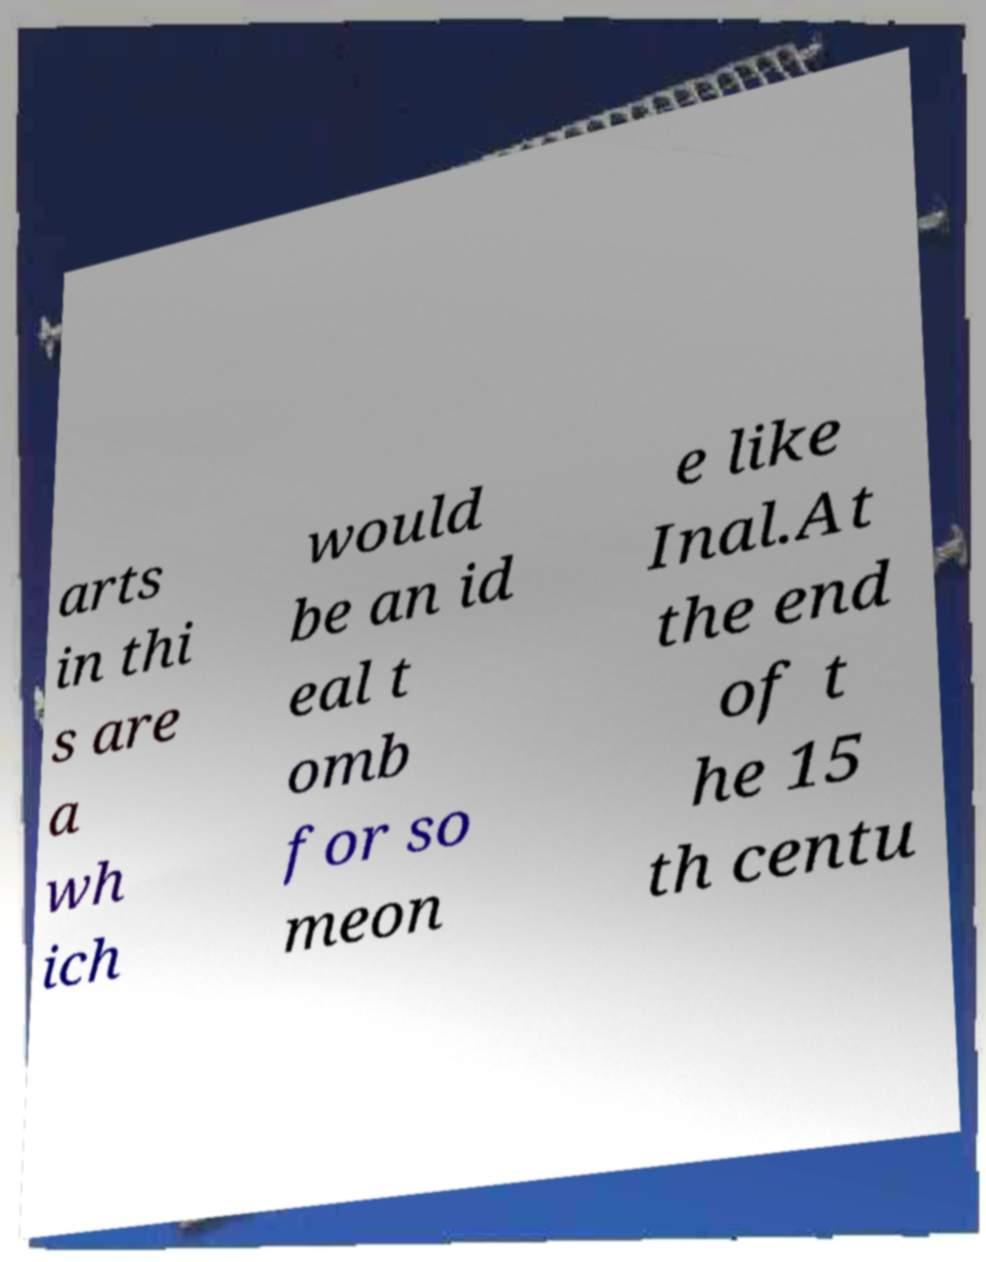For documentation purposes, I need the text within this image transcribed. Could you provide that? arts in thi s are a wh ich would be an id eal t omb for so meon e like Inal.At the end of t he 15 th centu 